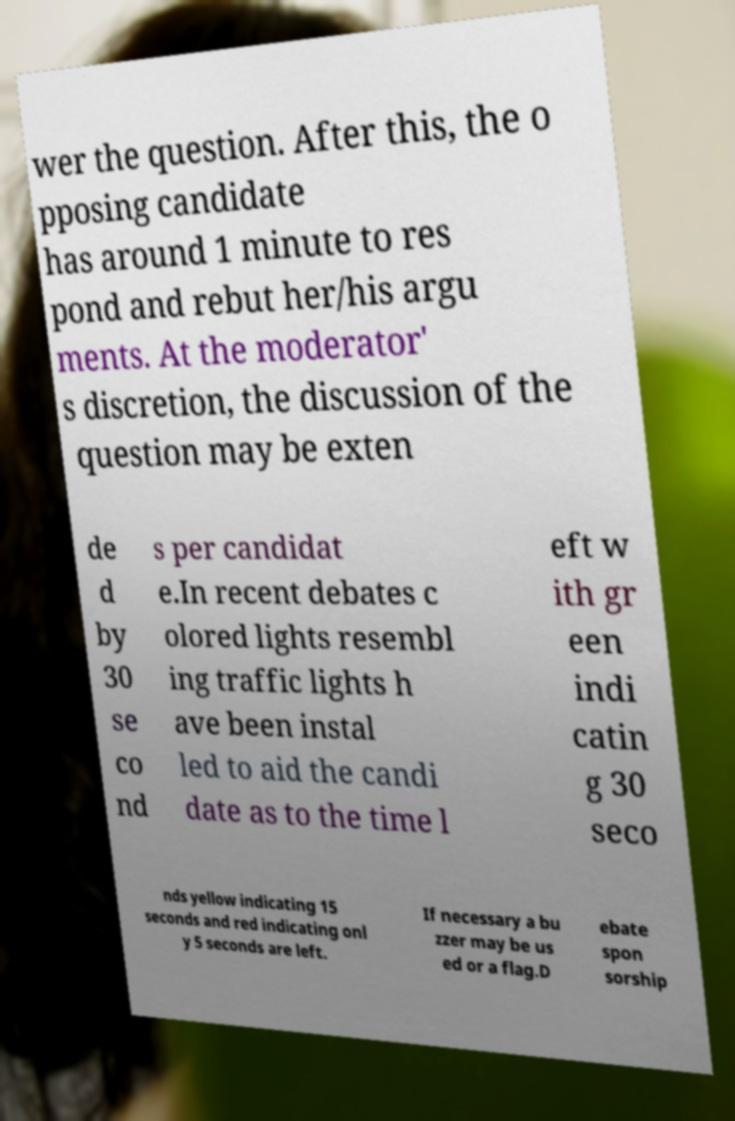Could you assist in decoding the text presented in this image and type it out clearly? wer the question. After this, the o pposing candidate has around 1 minute to res pond and rebut her/his argu ments. At the moderator' s discretion, the discussion of the question may be exten de d by 30 se co nd s per candidat e.In recent debates c olored lights resembl ing traffic lights h ave been instal led to aid the candi date as to the time l eft w ith gr een indi catin g 30 seco nds yellow indicating 15 seconds and red indicating onl y 5 seconds are left. If necessary a bu zzer may be us ed or a flag.D ebate spon sorship 